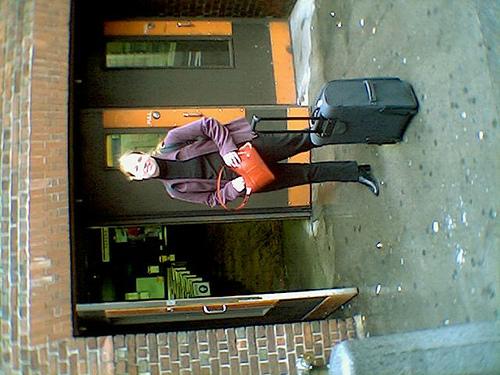Does the woman have a suitcase?
Give a very brief answer. Yes. Where is the woman's right hand?
Short answer required. Purse. Is the person lying down?
Answer briefly. No. 